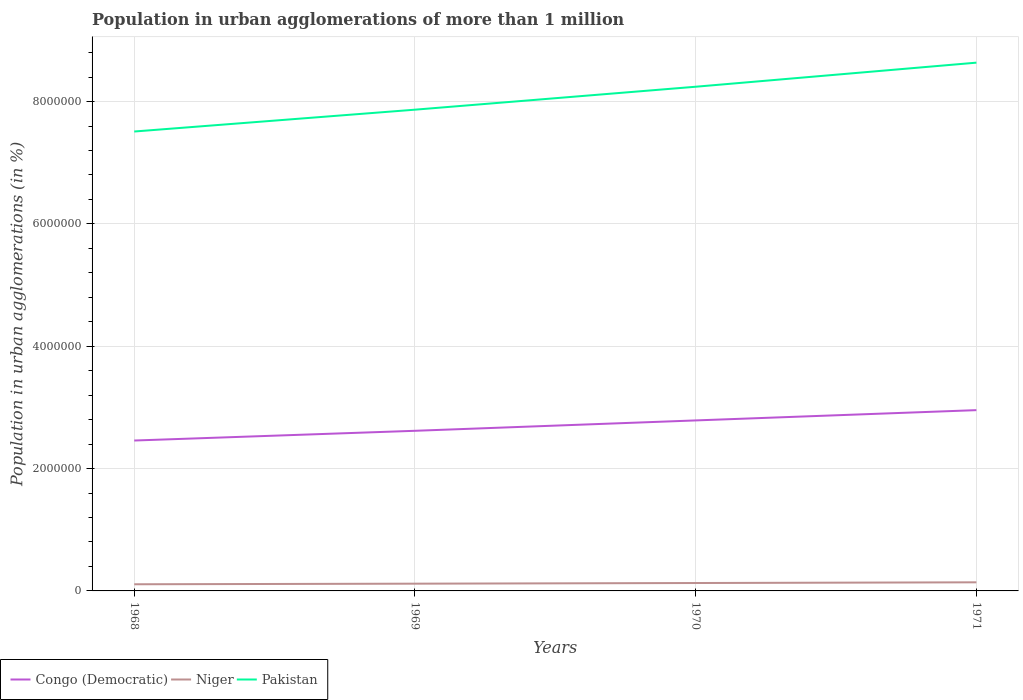How many different coloured lines are there?
Your response must be concise. 3. Does the line corresponding to Niger intersect with the line corresponding to Pakistan?
Provide a succinct answer. No. Across all years, what is the maximum population in urban agglomerations in Niger?
Offer a very short reply. 1.09e+05. In which year was the population in urban agglomerations in Pakistan maximum?
Ensure brevity in your answer.  1968. What is the total population in urban agglomerations in Congo (Democratic) in the graph?
Provide a succinct answer. -3.38e+05. What is the difference between the highest and the second highest population in urban agglomerations in Congo (Democratic)?
Offer a very short reply. 4.97e+05. How many lines are there?
Your answer should be very brief. 3. What is the difference between two consecutive major ticks on the Y-axis?
Your answer should be compact. 2.00e+06. Where does the legend appear in the graph?
Offer a very short reply. Bottom left. How many legend labels are there?
Offer a terse response. 3. How are the legend labels stacked?
Your answer should be compact. Horizontal. What is the title of the graph?
Make the answer very short. Population in urban agglomerations of more than 1 million. Does "Greece" appear as one of the legend labels in the graph?
Ensure brevity in your answer.  No. What is the label or title of the X-axis?
Keep it short and to the point. Years. What is the label or title of the Y-axis?
Ensure brevity in your answer.  Population in urban agglomerations (in %). What is the Population in urban agglomerations (in %) in Congo (Democratic) in 1968?
Ensure brevity in your answer.  2.46e+06. What is the Population in urban agglomerations (in %) in Niger in 1968?
Your answer should be very brief. 1.09e+05. What is the Population in urban agglomerations (in %) in Pakistan in 1968?
Your response must be concise. 7.51e+06. What is the Population in urban agglomerations (in %) of Congo (Democratic) in 1969?
Ensure brevity in your answer.  2.62e+06. What is the Population in urban agglomerations (in %) of Niger in 1969?
Provide a succinct answer. 1.19e+05. What is the Population in urban agglomerations (in %) in Pakistan in 1969?
Your answer should be very brief. 7.87e+06. What is the Population in urban agglomerations (in %) in Congo (Democratic) in 1970?
Make the answer very short. 2.79e+06. What is the Population in urban agglomerations (in %) of Niger in 1970?
Your answer should be very brief. 1.29e+05. What is the Population in urban agglomerations (in %) in Pakistan in 1970?
Your response must be concise. 8.24e+06. What is the Population in urban agglomerations (in %) of Congo (Democratic) in 1971?
Your answer should be very brief. 2.96e+06. What is the Population in urban agglomerations (in %) in Niger in 1971?
Offer a terse response. 1.41e+05. What is the Population in urban agglomerations (in %) in Pakistan in 1971?
Provide a succinct answer. 8.64e+06. Across all years, what is the maximum Population in urban agglomerations (in %) of Congo (Democratic)?
Provide a succinct answer. 2.96e+06. Across all years, what is the maximum Population in urban agglomerations (in %) of Niger?
Offer a very short reply. 1.41e+05. Across all years, what is the maximum Population in urban agglomerations (in %) of Pakistan?
Give a very brief answer. 8.64e+06. Across all years, what is the minimum Population in urban agglomerations (in %) in Congo (Democratic)?
Provide a succinct answer. 2.46e+06. Across all years, what is the minimum Population in urban agglomerations (in %) of Niger?
Ensure brevity in your answer.  1.09e+05. Across all years, what is the minimum Population in urban agglomerations (in %) in Pakistan?
Your response must be concise. 7.51e+06. What is the total Population in urban agglomerations (in %) of Congo (Democratic) in the graph?
Your answer should be compact. 1.08e+07. What is the total Population in urban agglomerations (in %) of Niger in the graph?
Give a very brief answer. 4.97e+05. What is the total Population in urban agglomerations (in %) of Pakistan in the graph?
Provide a succinct answer. 3.23e+07. What is the difference between the Population in urban agglomerations (in %) in Congo (Democratic) in 1968 and that in 1969?
Your response must be concise. -1.59e+05. What is the difference between the Population in urban agglomerations (in %) of Niger in 1968 and that in 1969?
Provide a succinct answer. -9704. What is the difference between the Population in urban agglomerations (in %) of Pakistan in 1968 and that in 1969?
Keep it short and to the point. -3.57e+05. What is the difference between the Population in urban agglomerations (in %) of Congo (Democratic) in 1968 and that in 1970?
Offer a terse response. -3.29e+05. What is the difference between the Population in urban agglomerations (in %) of Niger in 1968 and that in 1970?
Give a very brief answer. -2.03e+04. What is the difference between the Population in urban agglomerations (in %) of Pakistan in 1968 and that in 1970?
Give a very brief answer. -7.32e+05. What is the difference between the Population in urban agglomerations (in %) of Congo (Democratic) in 1968 and that in 1971?
Offer a terse response. -4.97e+05. What is the difference between the Population in urban agglomerations (in %) of Niger in 1968 and that in 1971?
Provide a succinct answer. -3.18e+04. What is the difference between the Population in urban agglomerations (in %) of Pakistan in 1968 and that in 1971?
Keep it short and to the point. -1.13e+06. What is the difference between the Population in urban agglomerations (in %) of Congo (Democratic) in 1969 and that in 1970?
Offer a very short reply. -1.70e+05. What is the difference between the Population in urban agglomerations (in %) in Niger in 1969 and that in 1970?
Your answer should be very brief. -1.06e+04. What is the difference between the Population in urban agglomerations (in %) in Pakistan in 1969 and that in 1970?
Offer a terse response. -3.75e+05. What is the difference between the Population in urban agglomerations (in %) of Congo (Democratic) in 1969 and that in 1971?
Your answer should be compact. -3.38e+05. What is the difference between the Population in urban agglomerations (in %) of Niger in 1969 and that in 1971?
Your response must be concise. -2.21e+04. What is the difference between the Population in urban agglomerations (in %) of Pakistan in 1969 and that in 1971?
Keep it short and to the point. -7.69e+05. What is the difference between the Population in urban agglomerations (in %) of Congo (Democratic) in 1970 and that in 1971?
Your response must be concise. -1.68e+05. What is the difference between the Population in urban agglomerations (in %) in Niger in 1970 and that in 1971?
Your response must be concise. -1.15e+04. What is the difference between the Population in urban agglomerations (in %) of Pakistan in 1970 and that in 1971?
Provide a short and direct response. -3.94e+05. What is the difference between the Population in urban agglomerations (in %) in Congo (Democratic) in 1968 and the Population in urban agglomerations (in %) in Niger in 1969?
Make the answer very short. 2.34e+06. What is the difference between the Population in urban agglomerations (in %) in Congo (Democratic) in 1968 and the Population in urban agglomerations (in %) in Pakistan in 1969?
Offer a very short reply. -5.41e+06. What is the difference between the Population in urban agglomerations (in %) of Niger in 1968 and the Population in urban agglomerations (in %) of Pakistan in 1969?
Offer a very short reply. -7.76e+06. What is the difference between the Population in urban agglomerations (in %) of Congo (Democratic) in 1968 and the Population in urban agglomerations (in %) of Niger in 1970?
Make the answer very short. 2.33e+06. What is the difference between the Population in urban agglomerations (in %) in Congo (Democratic) in 1968 and the Population in urban agglomerations (in %) in Pakistan in 1970?
Provide a short and direct response. -5.78e+06. What is the difference between the Population in urban agglomerations (in %) in Niger in 1968 and the Population in urban agglomerations (in %) in Pakistan in 1970?
Offer a very short reply. -8.13e+06. What is the difference between the Population in urban agglomerations (in %) in Congo (Democratic) in 1968 and the Population in urban agglomerations (in %) in Niger in 1971?
Keep it short and to the point. 2.32e+06. What is the difference between the Population in urban agglomerations (in %) in Congo (Democratic) in 1968 and the Population in urban agglomerations (in %) in Pakistan in 1971?
Your response must be concise. -6.18e+06. What is the difference between the Population in urban agglomerations (in %) in Niger in 1968 and the Population in urban agglomerations (in %) in Pakistan in 1971?
Provide a succinct answer. -8.53e+06. What is the difference between the Population in urban agglomerations (in %) in Congo (Democratic) in 1969 and the Population in urban agglomerations (in %) in Niger in 1970?
Ensure brevity in your answer.  2.49e+06. What is the difference between the Population in urban agglomerations (in %) in Congo (Democratic) in 1969 and the Population in urban agglomerations (in %) in Pakistan in 1970?
Offer a very short reply. -5.63e+06. What is the difference between the Population in urban agglomerations (in %) of Niger in 1969 and the Population in urban agglomerations (in %) of Pakistan in 1970?
Provide a succinct answer. -8.12e+06. What is the difference between the Population in urban agglomerations (in %) of Congo (Democratic) in 1969 and the Population in urban agglomerations (in %) of Niger in 1971?
Your answer should be compact. 2.48e+06. What is the difference between the Population in urban agglomerations (in %) of Congo (Democratic) in 1969 and the Population in urban agglomerations (in %) of Pakistan in 1971?
Give a very brief answer. -6.02e+06. What is the difference between the Population in urban agglomerations (in %) in Niger in 1969 and the Population in urban agglomerations (in %) in Pakistan in 1971?
Ensure brevity in your answer.  -8.52e+06. What is the difference between the Population in urban agglomerations (in %) of Congo (Democratic) in 1970 and the Population in urban agglomerations (in %) of Niger in 1971?
Provide a succinct answer. 2.65e+06. What is the difference between the Population in urban agglomerations (in %) of Congo (Democratic) in 1970 and the Population in urban agglomerations (in %) of Pakistan in 1971?
Offer a very short reply. -5.85e+06. What is the difference between the Population in urban agglomerations (in %) of Niger in 1970 and the Population in urban agglomerations (in %) of Pakistan in 1971?
Your response must be concise. -8.51e+06. What is the average Population in urban agglomerations (in %) of Congo (Democratic) per year?
Make the answer very short. 2.71e+06. What is the average Population in urban agglomerations (in %) in Niger per year?
Ensure brevity in your answer.  1.24e+05. What is the average Population in urban agglomerations (in %) of Pakistan per year?
Offer a terse response. 8.06e+06. In the year 1968, what is the difference between the Population in urban agglomerations (in %) in Congo (Democratic) and Population in urban agglomerations (in %) in Niger?
Make the answer very short. 2.35e+06. In the year 1968, what is the difference between the Population in urban agglomerations (in %) in Congo (Democratic) and Population in urban agglomerations (in %) in Pakistan?
Provide a succinct answer. -5.05e+06. In the year 1968, what is the difference between the Population in urban agglomerations (in %) of Niger and Population in urban agglomerations (in %) of Pakistan?
Offer a very short reply. -7.40e+06. In the year 1969, what is the difference between the Population in urban agglomerations (in %) of Congo (Democratic) and Population in urban agglomerations (in %) of Niger?
Ensure brevity in your answer.  2.50e+06. In the year 1969, what is the difference between the Population in urban agglomerations (in %) in Congo (Democratic) and Population in urban agglomerations (in %) in Pakistan?
Provide a short and direct response. -5.25e+06. In the year 1969, what is the difference between the Population in urban agglomerations (in %) of Niger and Population in urban agglomerations (in %) of Pakistan?
Provide a short and direct response. -7.75e+06. In the year 1970, what is the difference between the Population in urban agglomerations (in %) of Congo (Democratic) and Population in urban agglomerations (in %) of Niger?
Your response must be concise. 2.66e+06. In the year 1970, what is the difference between the Population in urban agglomerations (in %) of Congo (Democratic) and Population in urban agglomerations (in %) of Pakistan?
Provide a succinct answer. -5.46e+06. In the year 1970, what is the difference between the Population in urban agglomerations (in %) in Niger and Population in urban agglomerations (in %) in Pakistan?
Your response must be concise. -8.11e+06. In the year 1971, what is the difference between the Population in urban agglomerations (in %) in Congo (Democratic) and Population in urban agglomerations (in %) in Niger?
Make the answer very short. 2.81e+06. In the year 1971, what is the difference between the Population in urban agglomerations (in %) in Congo (Democratic) and Population in urban agglomerations (in %) in Pakistan?
Your response must be concise. -5.68e+06. In the year 1971, what is the difference between the Population in urban agglomerations (in %) in Niger and Population in urban agglomerations (in %) in Pakistan?
Provide a short and direct response. -8.50e+06. What is the ratio of the Population in urban agglomerations (in %) of Congo (Democratic) in 1968 to that in 1969?
Your answer should be very brief. 0.94. What is the ratio of the Population in urban agglomerations (in %) of Niger in 1968 to that in 1969?
Make the answer very short. 0.92. What is the ratio of the Population in urban agglomerations (in %) of Pakistan in 1968 to that in 1969?
Your answer should be very brief. 0.95. What is the ratio of the Population in urban agglomerations (in %) in Congo (Democratic) in 1968 to that in 1970?
Give a very brief answer. 0.88. What is the ratio of the Population in urban agglomerations (in %) of Niger in 1968 to that in 1970?
Offer a terse response. 0.84. What is the ratio of the Population in urban agglomerations (in %) of Pakistan in 1968 to that in 1970?
Offer a very short reply. 0.91. What is the ratio of the Population in urban agglomerations (in %) of Congo (Democratic) in 1968 to that in 1971?
Provide a succinct answer. 0.83. What is the ratio of the Population in urban agglomerations (in %) in Niger in 1968 to that in 1971?
Provide a succinct answer. 0.77. What is the ratio of the Population in urban agglomerations (in %) of Pakistan in 1968 to that in 1971?
Your response must be concise. 0.87. What is the ratio of the Population in urban agglomerations (in %) in Congo (Democratic) in 1969 to that in 1970?
Your answer should be compact. 0.94. What is the ratio of the Population in urban agglomerations (in %) of Niger in 1969 to that in 1970?
Offer a terse response. 0.92. What is the ratio of the Population in urban agglomerations (in %) of Pakistan in 1969 to that in 1970?
Your response must be concise. 0.95. What is the ratio of the Population in urban agglomerations (in %) of Congo (Democratic) in 1969 to that in 1971?
Offer a very short reply. 0.89. What is the ratio of the Population in urban agglomerations (in %) in Niger in 1969 to that in 1971?
Make the answer very short. 0.84. What is the ratio of the Population in urban agglomerations (in %) in Pakistan in 1969 to that in 1971?
Your answer should be compact. 0.91. What is the ratio of the Population in urban agglomerations (in %) in Congo (Democratic) in 1970 to that in 1971?
Ensure brevity in your answer.  0.94. What is the ratio of the Population in urban agglomerations (in %) of Niger in 1970 to that in 1971?
Provide a succinct answer. 0.92. What is the ratio of the Population in urban agglomerations (in %) in Pakistan in 1970 to that in 1971?
Offer a very short reply. 0.95. What is the difference between the highest and the second highest Population in urban agglomerations (in %) in Congo (Democratic)?
Offer a very short reply. 1.68e+05. What is the difference between the highest and the second highest Population in urban agglomerations (in %) in Niger?
Ensure brevity in your answer.  1.15e+04. What is the difference between the highest and the second highest Population in urban agglomerations (in %) of Pakistan?
Keep it short and to the point. 3.94e+05. What is the difference between the highest and the lowest Population in urban agglomerations (in %) in Congo (Democratic)?
Keep it short and to the point. 4.97e+05. What is the difference between the highest and the lowest Population in urban agglomerations (in %) in Niger?
Give a very brief answer. 3.18e+04. What is the difference between the highest and the lowest Population in urban agglomerations (in %) of Pakistan?
Make the answer very short. 1.13e+06. 